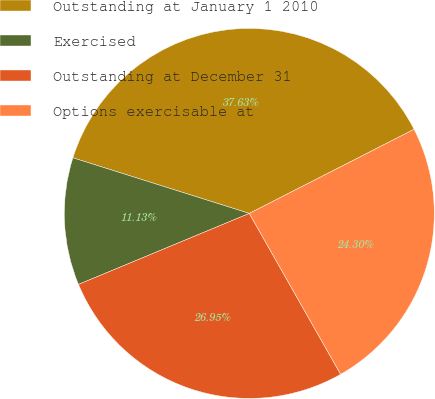<chart> <loc_0><loc_0><loc_500><loc_500><pie_chart><fcel>Outstanding at January 1 2010<fcel>Exercised<fcel>Outstanding at December 31<fcel>Options exercisable at<nl><fcel>37.63%<fcel>11.13%<fcel>26.95%<fcel>24.3%<nl></chart> 